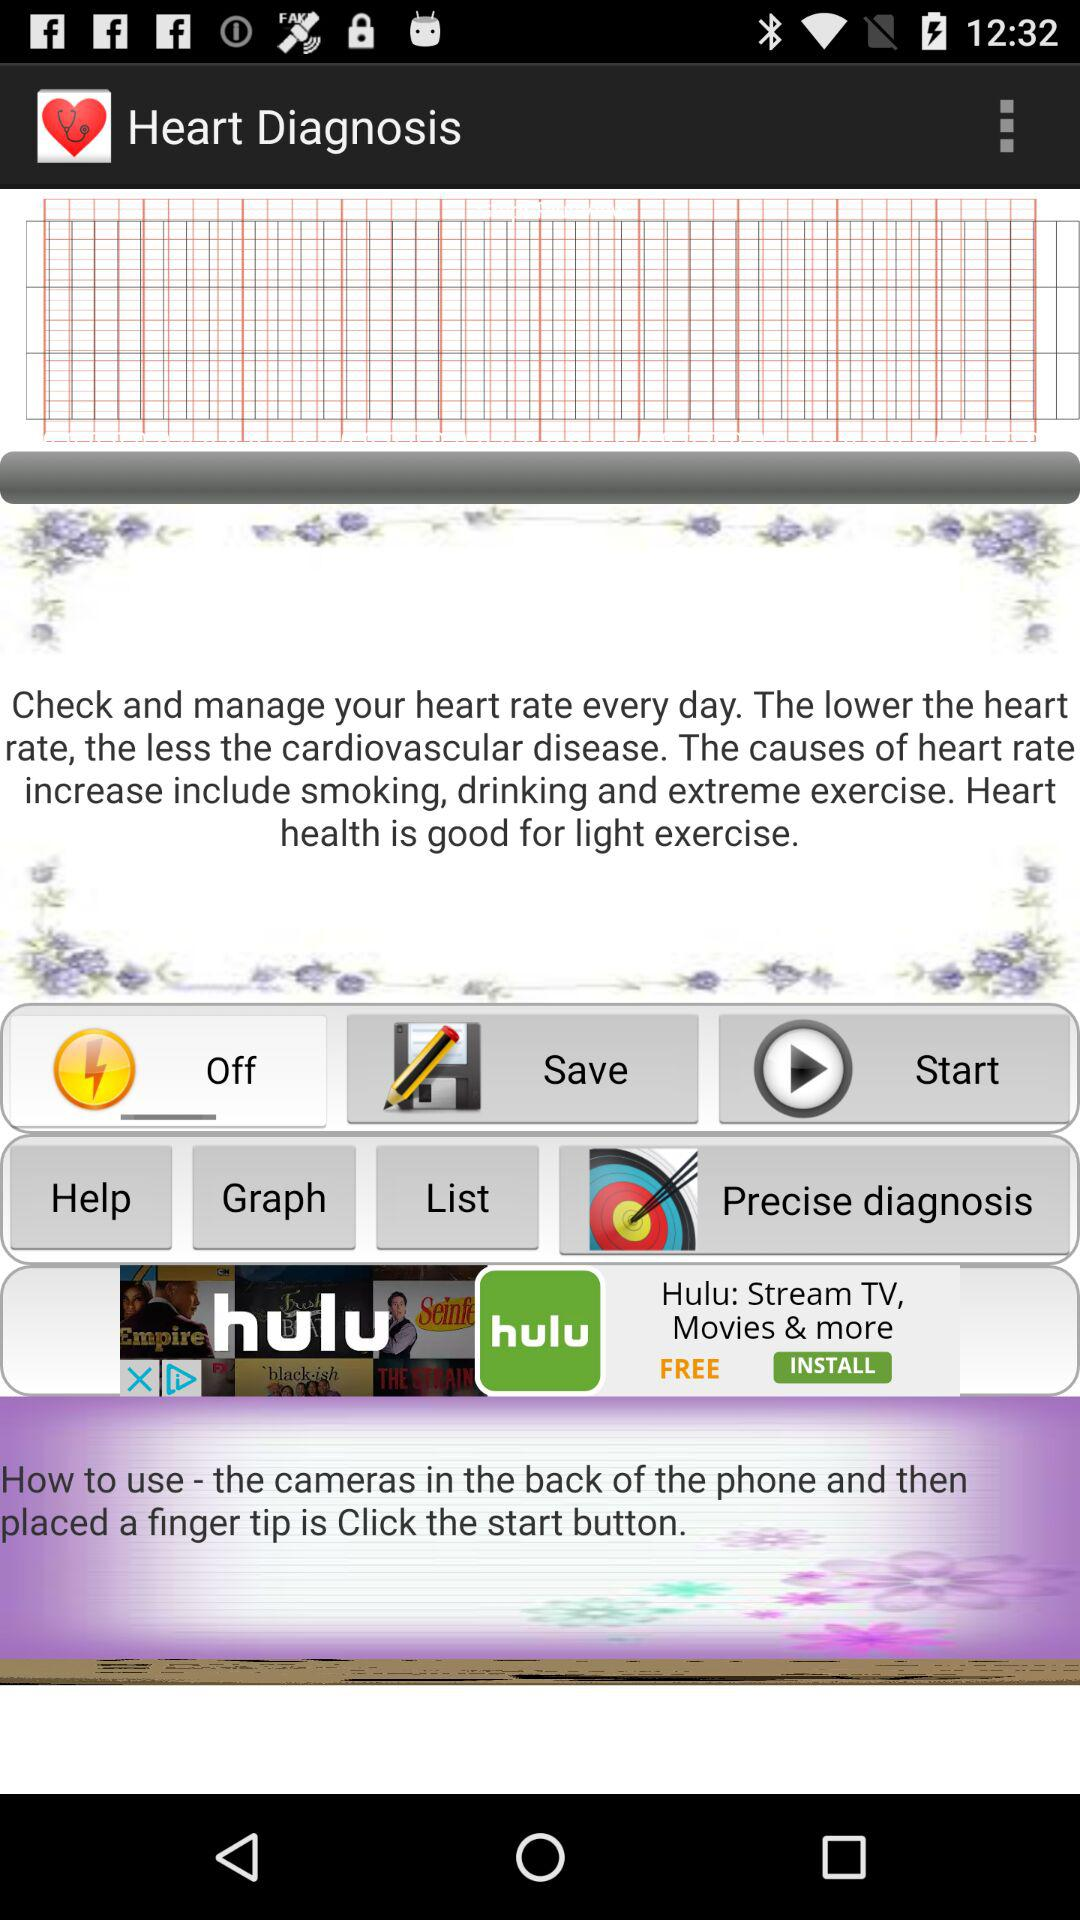What is the precise diagnosis?
When the provided information is insufficient, respond with <no answer>. <no answer> 